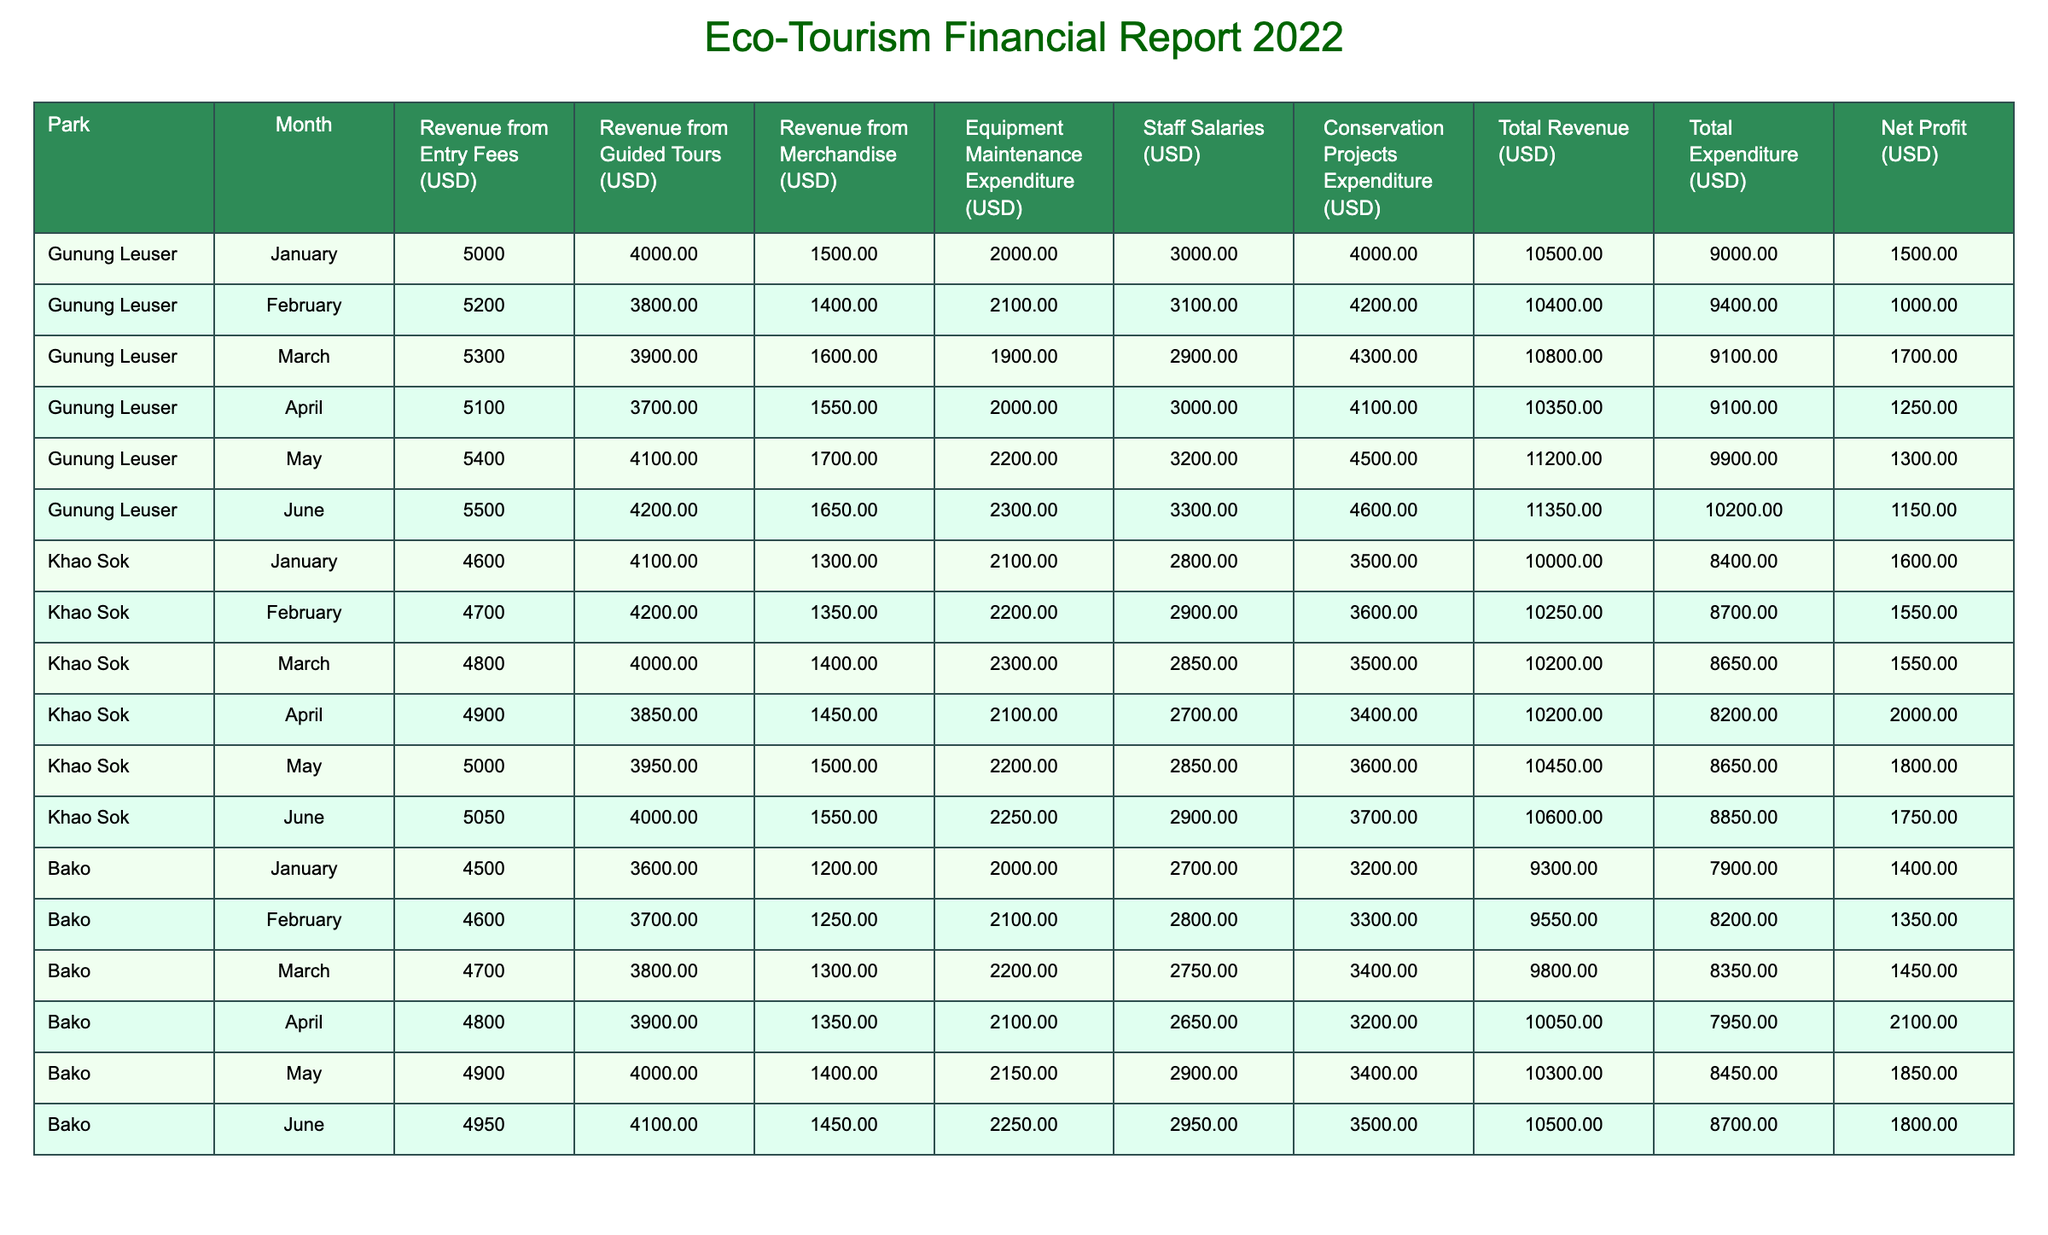What is the total revenue from entry fees for Gunung Leuser in May? The revenue from entry fees specifically for Gunung Leuser in May is listed as 5400 USD in the table.
Answer: 5400 USD What was the total expenditure for Khao Sok in April? In April, Khao Sok's total expenditure is provided in the table as 8200 USD.
Answer: 8200 USD Which park had the highest total revenue in June? In June, the total revenue for Gunung Leuser is 11350 USD, for Khao Sok is 10600 USD, and for Bako is 10500 USD. The highest total revenue in June is from Gunung Leuser.
Answer: Gunung Leuser What is the average revenue from merchandise across all parks in January? The merchandise revenue for January across all parks is 1500 (Gunung Leuser) + 1300 (Khao Sok) + 1200 (Bako) = 4000 USD. There are 3 parks, so the average is 4000 / 3 = 1333.33 USD.
Answer: 1333.33 USD Is the total revenue from guided tours in February for Bako greater than that for Khao Sok? Bako's revenue from guided tours in February is 3700 USD, while Khao Sok's is 4200 USD. Since 3700 is less than 4200, the statement is false.
Answer: No What is the net profit for Gunung Leuser in March? The total revenue for Gunung Leuser in March is 10800 USD, and the total expenditure is 9100 USD. The net profit is calculated as 10800 - 9100 = 1700 USD.
Answer: 1700 USD What is the highest conservation project expenditure listed in the table? By examining the conservation project expenditures for each month and park, the highest value is 4600 USD for Gunung Leuser in June.
Answer: 4600 USD Which park had the least revenue from entry fees in February? In February, the entry fee revenues are 5200 USD (Gunung Leuser), 4700 USD (Khao Sok), and 4600 USD (Bako). Bako has the lowest entry fee revenue.
Answer: Bako If we consider the total revenue from all parks in May, what is the sum? In May, the total revenues are 11200 (Gunung Leuser) + 10450 (Khao Sok) + 10300 (Bako) = 31950 USD.
Answer: 31950 USD 